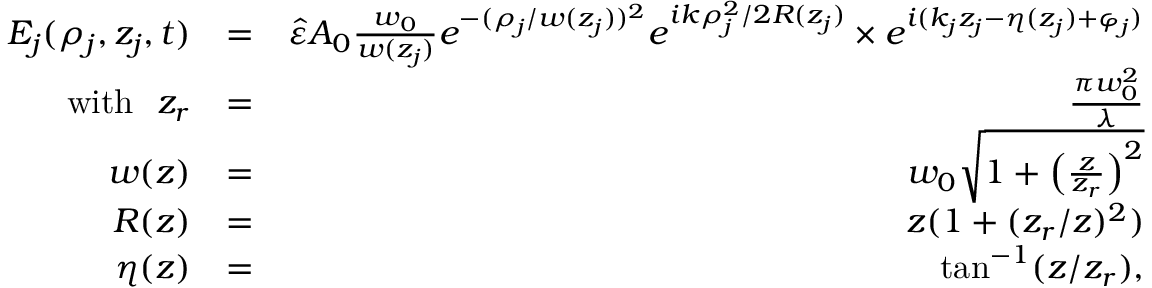Convert formula to latex. <formula><loc_0><loc_0><loc_500><loc_500>\begin{array} { r l r } { E _ { j } ( \rho _ { j } , z _ { j } , t ) } & { = } & { \hat { \varepsilon } A _ { 0 } \frac { w _ { 0 } } { w ( z _ { j } ) } e ^ { - ( \rho _ { j } / w ( z _ { j } ) ) ^ { 2 } } e ^ { i k \rho _ { j } ^ { 2 } / 2 R ( z _ { j } ) } \times e ^ { i ( k _ { j } z _ { j } - \eta ( z _ { j } ) + \varphi _ { j } ) } } \\ { w i t h z _ { r } } & { = } & { \frac { \pi w _ { 0 } ^ { 2 } } { \lambda } } \\ { w ( z ) } & { = } & { w _ { 0 } \sqrt { 1 + \left ( \frac { z } { z _ { r } } \right ) ^ { 2 } } } \\ { R ( z ) } & { = } & { z ( 1 + ( z _ { r } / z ) ^ { 2 } ) } \\ { \eta ( z ) } & { = } & { \tan ^ { - 1 } ( z / z _ { r } ) , } \end{array}</formula> 